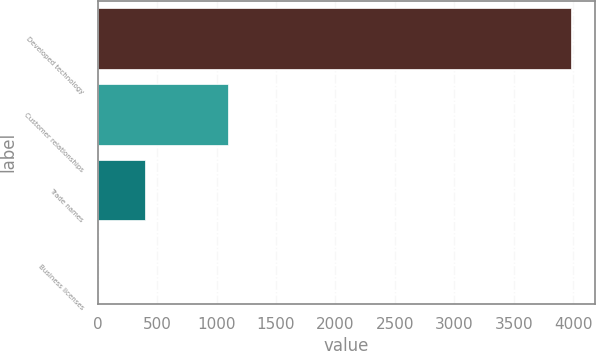Convert chart to OTSL. <chart><loc_0><loc_0><loc_500><loc_500><bar_chart><fcel>Developed technology<fcel>Customer relationships<fcel>Trade names<fcel>Business licenses<nl><fcel>3983.7<fcel>1098.9<fcel>400.53<fcel>2.4<nl></chart> 